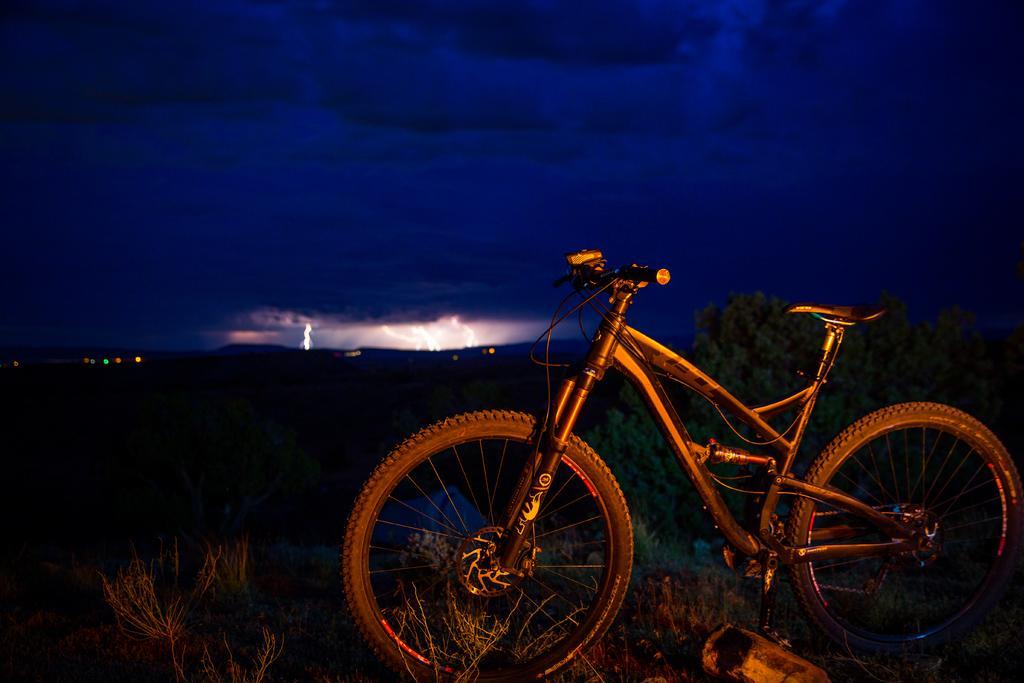Please provide a concise description of this image. In the foreground of this image, there is a bike and on the bottom, it seems like a bottle on the grass and we can also see few plants. In the dark background, on the top, there is the cloud and the thunder. 